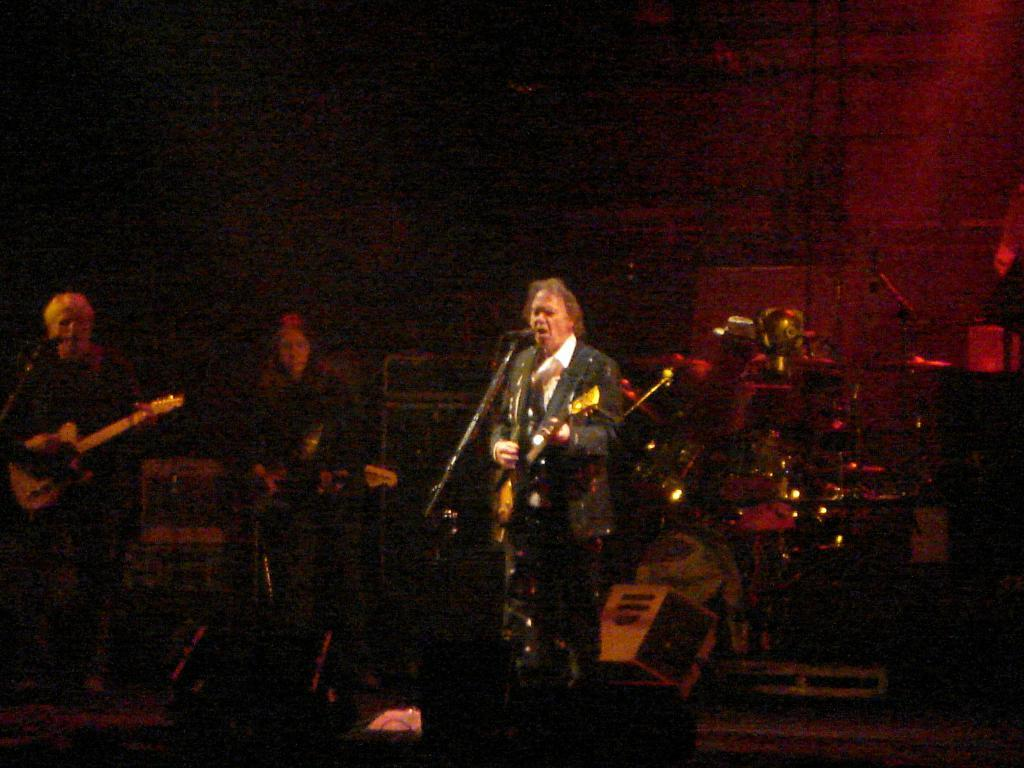How many people are in the image? There are people in the image, but the exact number is not specified. What are the people doing in the image? The people are standing and holding a guitar in their hands. What other musical instruments can be seen in the image? There are drums in the background of the image. What object might be used for amplifying sound in the image? There is a speaker in the background of the image. What type of powder can be seen falling from the guitar in the image? There is no powder falling from the guitar in the image. What scent is associated with the people in the image? There is no information about the scent of the people or the image. 